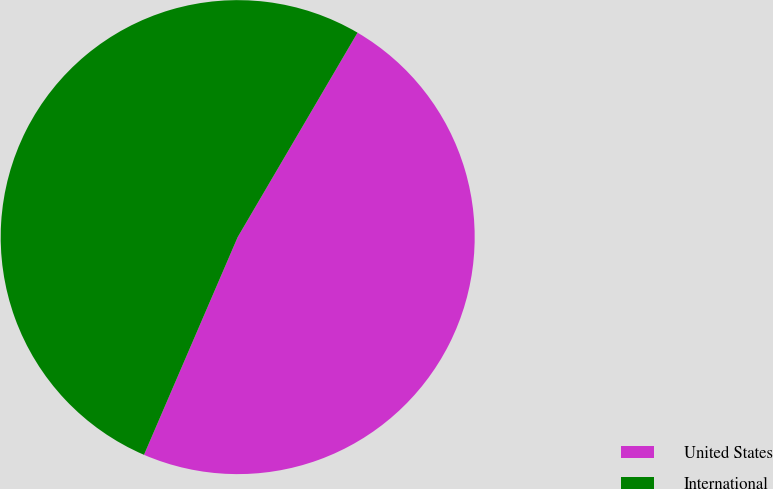<chart> <loc_0><loc_0><loc_500><loc_500><pie_chart><fcel>United States<fcel>International<nl><fcel>48.03%<fcel>51.97%<nl></chart> 